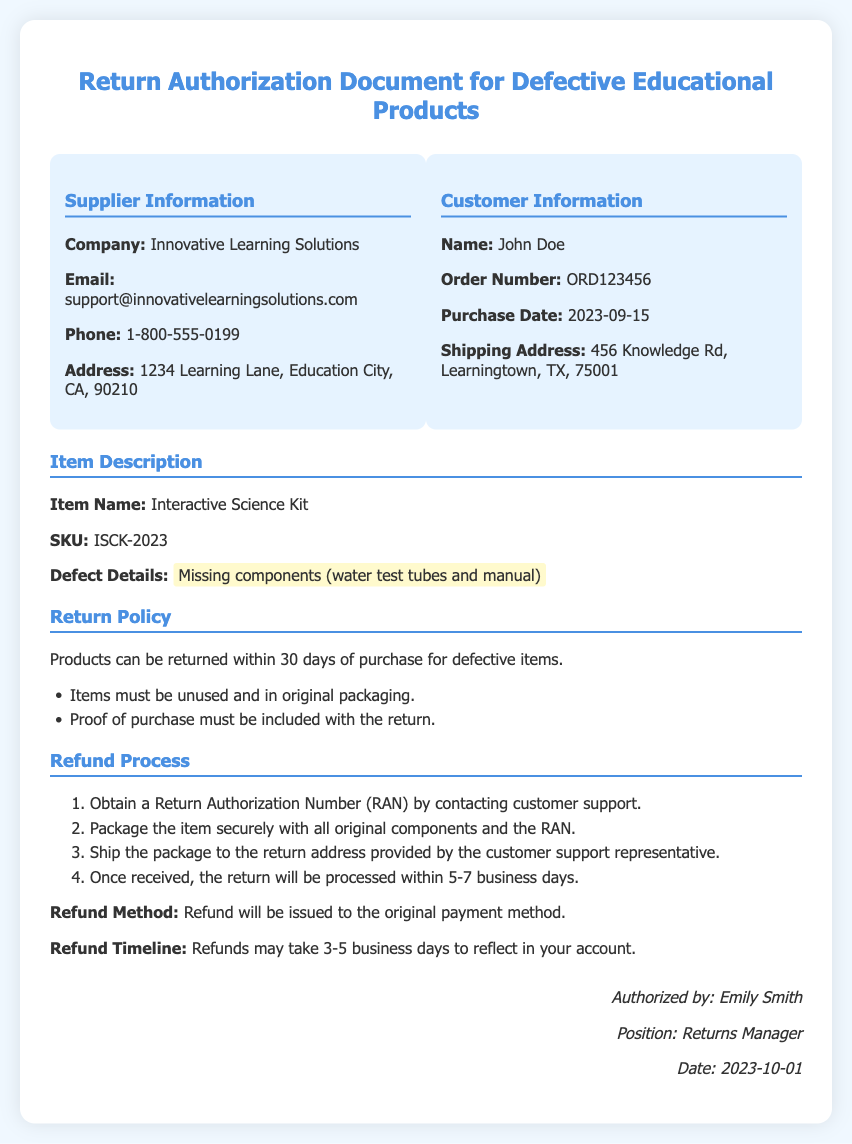What is the company name? The company name is listed in the supplier information section of the document.
Answer: Innovative Learning Solutions What is the order number? The order number can be found in the customer information section of the document.
Answer: ORD123456 What is the purchase date? The purchase date is detailed in the customer information section.
Answer: 2023-09-15 What defect details are mentioned? The defect details describe the specific issue with the product in the item description section.
Answer: Missing components (water test tubes and manual) What is the return window for defective items? The return policy specifies the time frame for returns related to defective items.
Answer: 30 days How long does the refund process take? The refund process section indicates the expected time frame for processing refunds.
Answer: 5-7 business days What must be included with the return? This information is included in the return policy section of the document.
Answer: Proof of purchase What is the refund method? The refund method indicates how funds will be returned to the customer, and is specified in the refund process section.
Answer: Original payment method Who is the authorized person for this document? The signature section of the document provides information about the person who authorized it.
Answer: Emily Smith What is the refund timeline for reflecting in the account? The refund process section outlines the expected timeline for refunds to appear in the customer's account.
Answer: 3-5 business days 